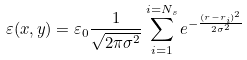<formula> <loc_0><loc_0><loc_500><loc_500>\varepsilon ( { x , y } ) = \varepsilon _ { 0 } \frac { 1 } { \sqrt { 2 \pi \sigma ^ { 2 } } } \sum _ { i = 1 } ^ { i = N _ { s } } e ^ { - \frac { ( { r } - { r } _ { i } ) ^ { 2 } } { 2 \sigma ^ { 2 } } }</formula> 